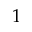Convert formula to latex. <formula><loc_0><loc_0><loc_500><loc_500>1</formula> 